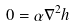<formula> <loc_0><loc_0><loc_500><loc_500>0 = \alpha \nabla ^ { 2 } h</formula> 